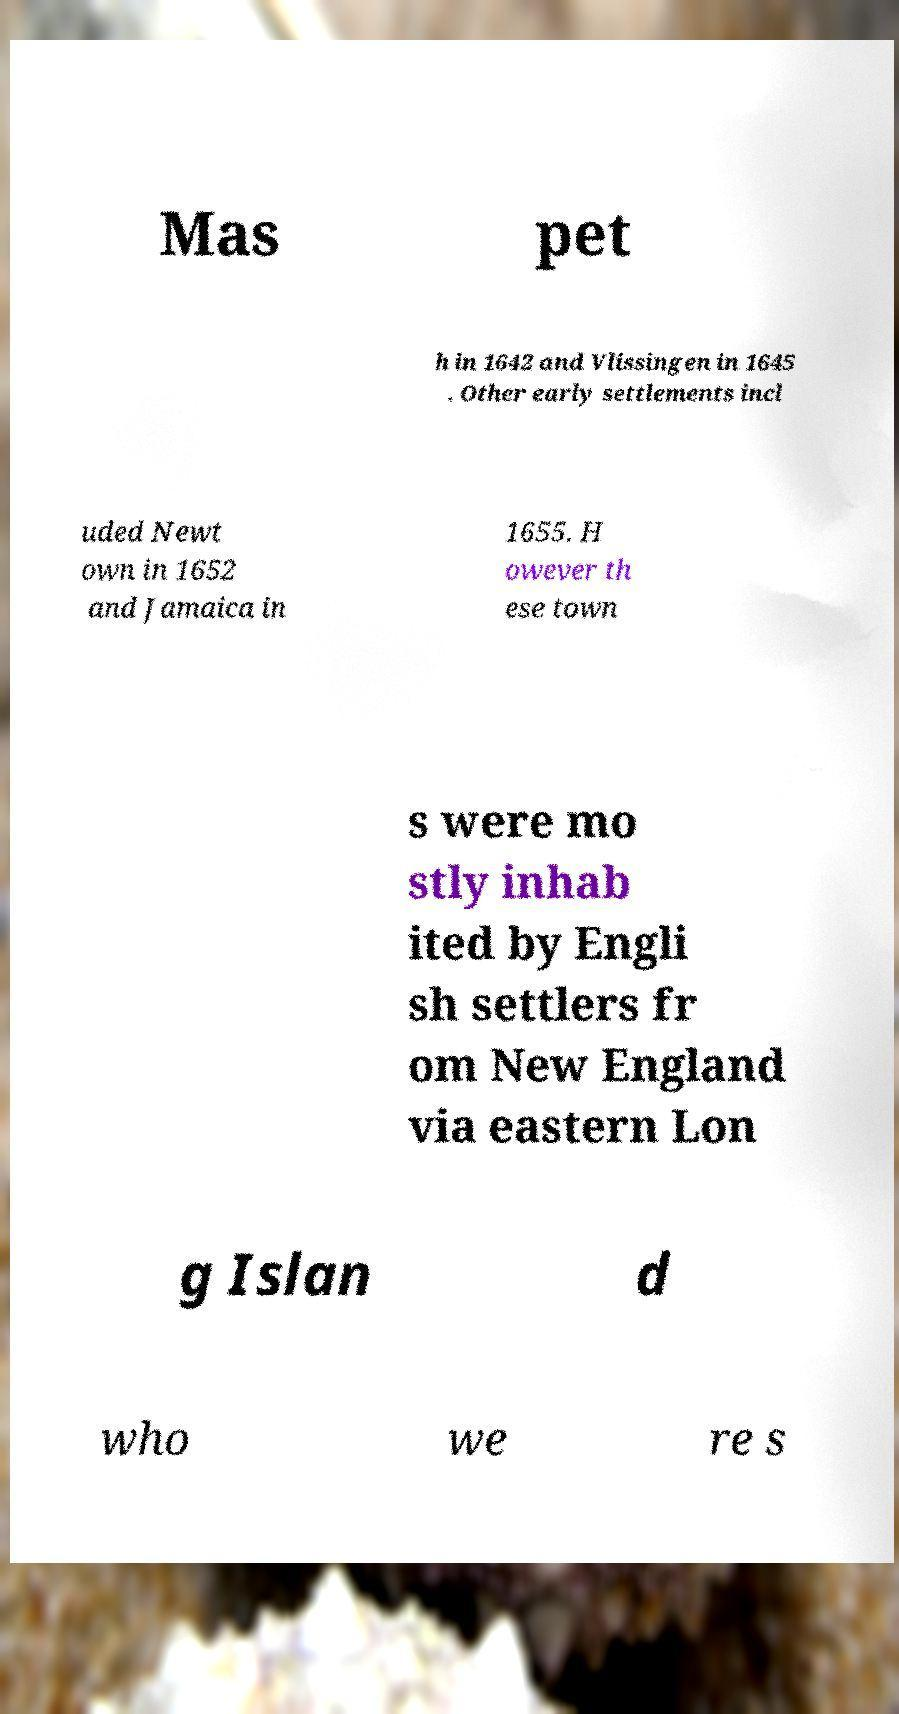Please identify and transcribe the text found in this image. Mas pet h in 1642 and Vlissingen in 1645 . Other early settlements incl uded Newt own in 1652 and Jamaica in 1655. H owever th ese town s were mo stly inhab ited by Engli sh settlers fr om New England via eastern Lon g Islan d who we re s 